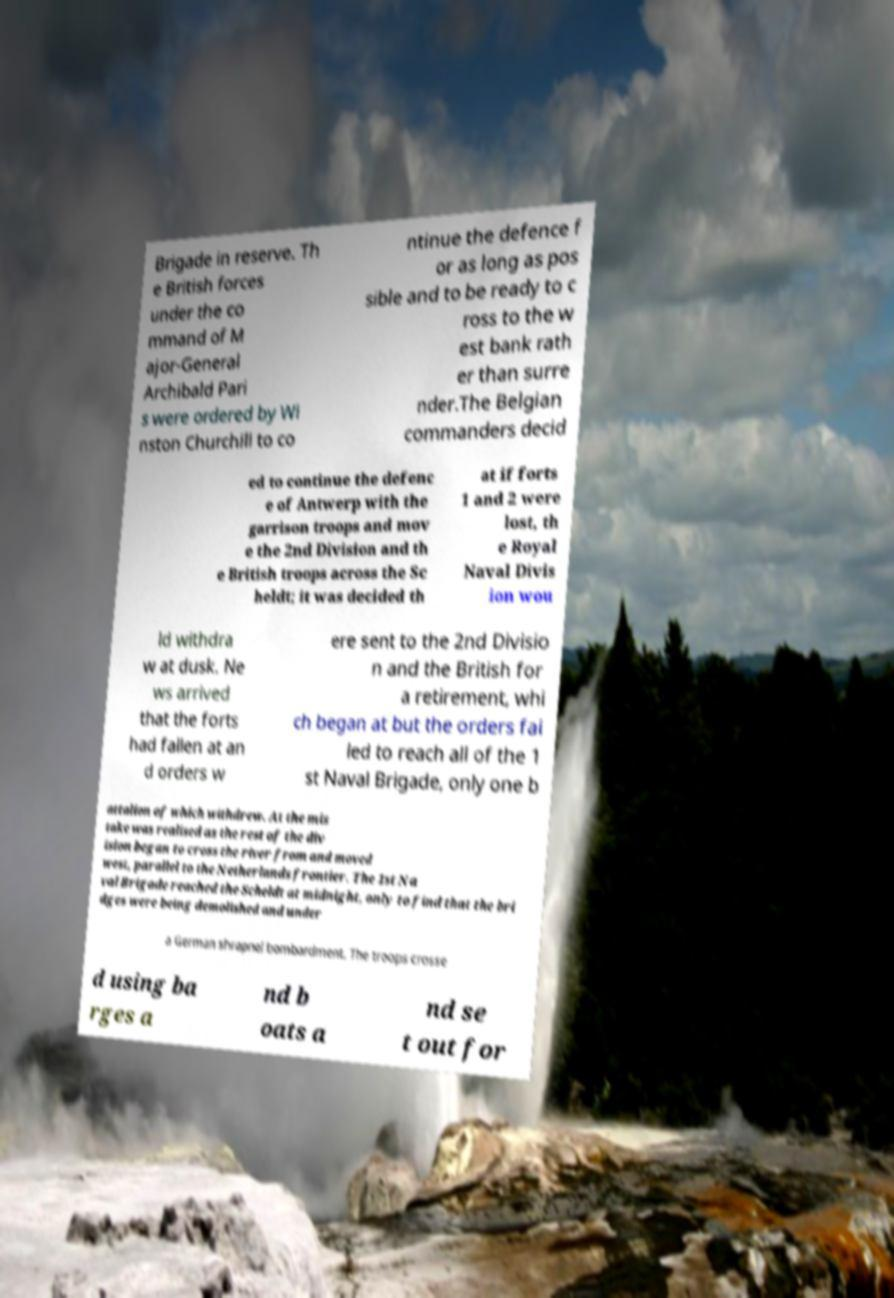Please identify and transcribe the text found in this image. Brigade in reserve. Th e British forces under the co mmand of M ajor-General Archibald Pari s were ordered by Wi nston Churchill to co ntinue the defence f or as long as pos sible and to be ready to c ross to the w est bank rath er than surre nder.The Belgian commanders decid ed to continue the defenc e of Antwerp with the garrison troops and mov e the 2nd Division and th e British troops across the Sc heldt; it was decided th at if forts 1 and 2 were lost, th e Royal Naval Divis ion wou ld withdra w at dusk. Ne ws arrived that the forts had fallen at an d orders w ere sent to the 2nd Divisio n and the British for a retirement, whi ch began at but the orders fai led to reach all of the 1 st Naval Brigade, only one b attalion of which withdrew. At the mis take was realised as the rest of the div ision began to cross the river from and moved west, parallel to the Netherlands frontier. The 1st Na val Brigade reached the Scheldt at midnight, only to find that the bri dges were being demolished and under a German shrapnel bombardment. The troops crosse d using ba rges a nd b oats a nd se t out for 